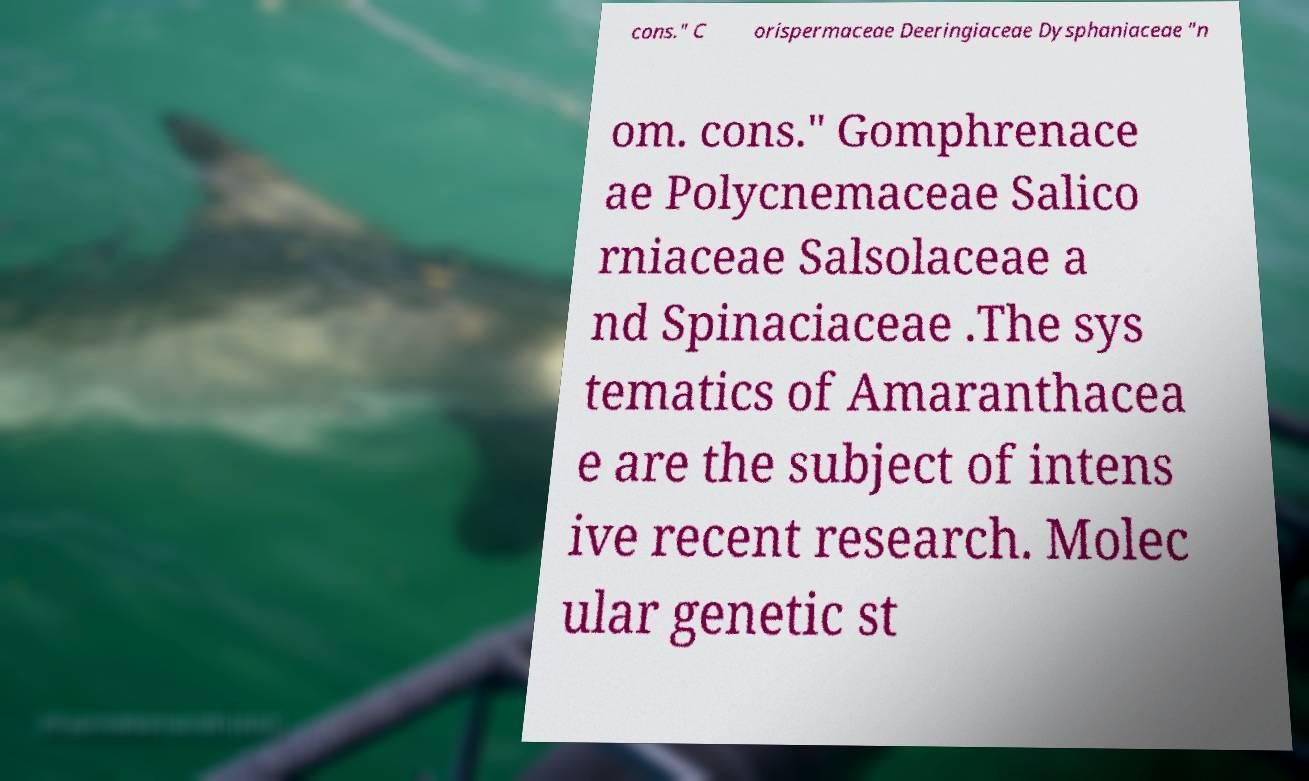Could you extract and type out the text from this image? cons." C orispermaceae Deeringiaceae Dysphaniaceae "n om. cons." Gomphrenace ae Polycnemaceae Salico rniaceae Salsolaceae a nd Spinaciaceae .The sys tematics of Amaranthacea e are the subject of intens ive recent research. Molec ular genetic st 